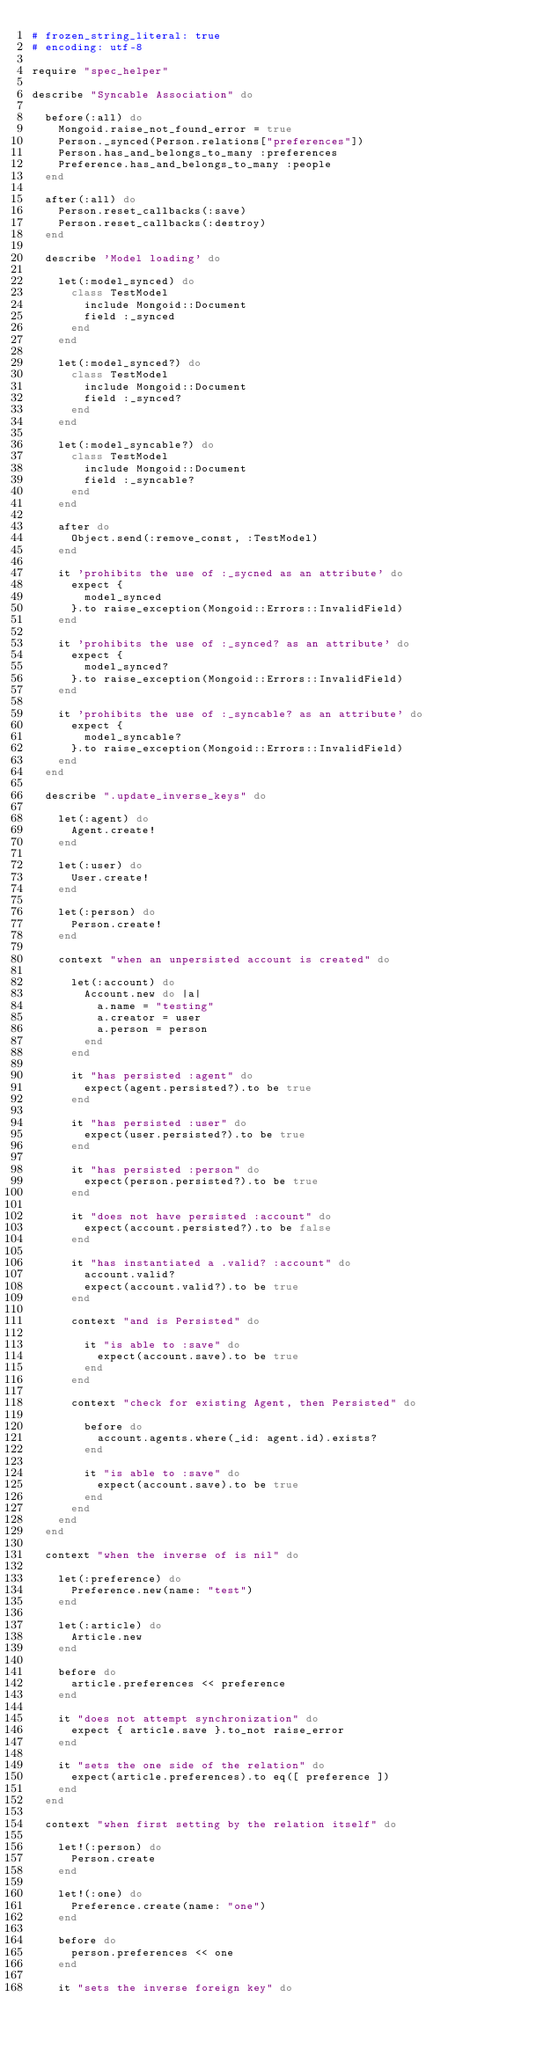Convert code to text. <code><loc_0><loc_0><loc_500><loc_500><_Ruby_># frozen_string_literal: true
# encoding: utf-8

require "spec_helper"

describe "Syncable Association" do

  before(:all) do
    Mongoid.raise_not_found_error = true
    Person._synced(Person.relations["preferences"])
    Person.has_and_belongs_to_many :preferences
    Preference.has_and_belongs_to_many :people
  end

  after(:all) do
    Person.reset_callbacks(:save)
    Person.reset_callbacks(:destroy)
  end

  describe 'Model loading' do

    let(:model_synced) do
      class TestModel
        include Mongoid::Document
        field :_synced
      end
    end

    let(:model_synced?) do
      class TestModel
        include Mongoid::Document
        field :_synced?
      end
    end

    let(:model_syncable?) do
      class TestModel
        include Mongoid::Document
        field :_syncable?
      end
    end

    after do
      Object.send(:remove_const, :TestModel)
    end

    it 'prohibits the use of :_sycned as an attribute' do
      expect {
        model_synced
      }.to raise_exception(Mongoid::Errors::InvalidField)
    end

    it 'prohibits the use of :_synced? as an attribute' do
      expect {
        model_synced?
      }.to raise_exception(Mongoid::Errors::InvalidField)
    end

    it 'prohibits the use of :_syncable? as an attribute' do
      expect {
        model_syncable?
      }.to raise_exception(Mongoid::Errors::InvalidField)
    end
  end

  describe ".update_inverse_keys" do

    let(:agent) do
      Agent.create!
    end

    let(:user) do
      User.create!
    end

    let(:person) do
      Person.create!
    end

    context "when an unpersisted account is created" do

      let(:account) do
        Account.new do |a|
          a.name = "testing"
          a.creator = user
          a.person = person
        end
      end

      it "has persisted :agent" do
        expect(agent.persisted?).to be true
      end

      it "has persisted :user" do
        expect(user.persisted?).to be true
      end

      it "has persisted :person" do
        expect(person.persisted?).to be true
      end

      it "does not have persisted :account" do
        expect(account.persisted?).to be false
      end

      it "has instantiated a .valid? :account" do
        account.valid?
        expect(account.valid?).to be true
      end

      context "and is Persisted" do

        it "is able to :save" do
          expect(account.save).to be true
        end
      end

      context "check for existing Agent, then Persisted" do

        before do
          account.agents.where(_id: agent.id).exists?
        end

        it "is able to :save" do
          expect(account.save).to be true
        end
      end
    end
  end

  context "when the inverse of is nil" do

    let(:preference) do
      Preference.new(name: "test")
    end

    let(:article) do
      Article.new
    end

    before do
      article.preferences << preference
    end

    it "does not attempt synchronization" do
      expect { article.save }.to_not raise_error
    end

    it "sets the one side of the relation" do
      expect(article.preferences).to eq([ preference ])
    end
  end

  context "when first setting by the relation itself" do

    let!(:person) do
      Person.create
    end

    let!(:one) do
      Preference.create(name: "one")
    end

    before do
      person.preferences << one
    end

    it "sets the inverse foreign key" do</code> 